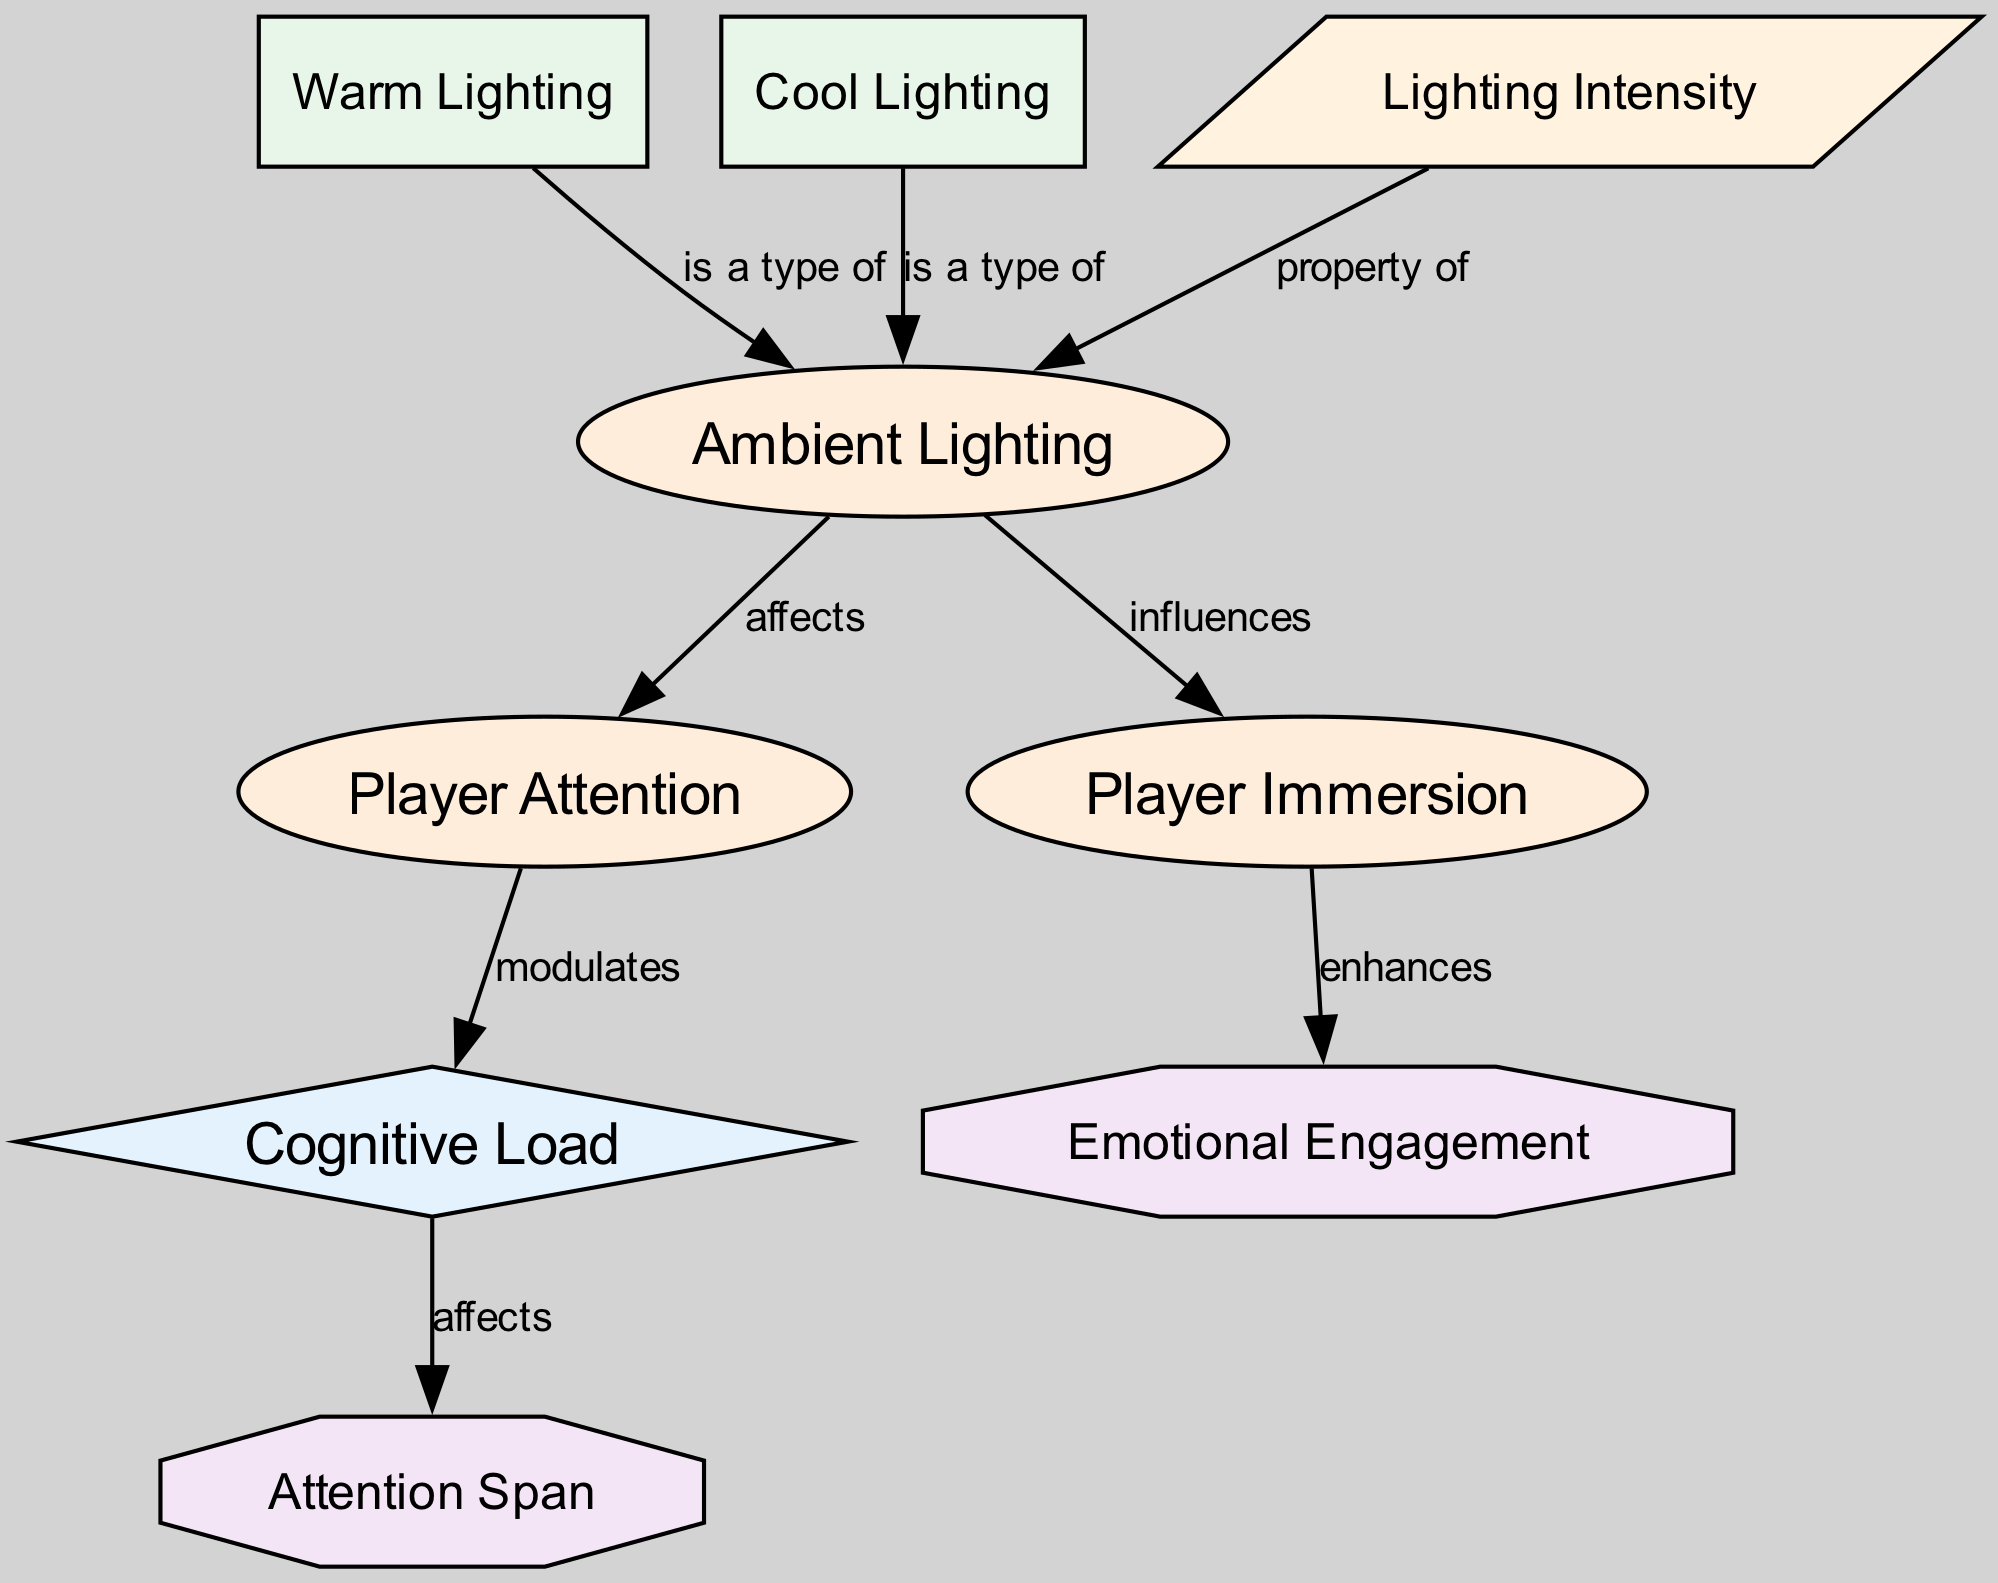What is the label of the node that represents player involvement? The node representing player involvement is labeled "Player Immersion" which shows the conceptual aspect of how ambient lighting influences the level of immersion players feel when engaging with video games.
Answer: Player Immersion How many nodes are there in the diagram? By counting each of the listed nodes under the "nodes" section in the diagram data, we find there are eight distinct nodes which include concepts, mechanisms, types, properties, and attributes.
Answer: 8 What type of relationship exists between Ambient Lighting and Player Attention? The relationship between Ambient Lighting and Player Attention is characterized as affecting, indicating that changes in ambient lighting directly influence how much attention players pay in the game.
Answer: affects Which two types of lighting are identified in the diagram? The two types of lighting identified in the diagram are "Warm Lighting" and "Cool Lighting," which serve as examples of how ambient lighting can be categorized within the context of visual games.
Answer: Warm Lighting, Cool Lighting What does Player Immersion enhance according to the diagram? The diagram states that Player Immersion enhances Emotional Engagement, highlighting the connection that deeper immersion can lead to increased emotional involvement in the gaming experience.
Answer: Emotional Engagement What effect does Cognitive Load have on Attention Span? The diagram indicates that Cognitive Load affects Attention Span, revealing that the mental effort put into processing information can influence how long players can maintain their attention.
Answer: affects What is a property of Ambient Lighting? The diagram specifies that Lighting Intensity is a property of Ambient Lighting, representing how the brightness level in the environment can influence player experience.
Answer: Lighting Intensity How does Player Attention modulate Cognitive Load? According to the diagram, Player Attention modulates Cognitive Load, signifying that higher levels of attention can either increase or decrease the cognitive load depending on the context of the game experience.
Answer: modulates How do Lighting types contribute to Ambient Lighting? The diagram shows that both Warm Lighting and Cool Lighting are types of Ambient Lighting, indicating that they fall under this broader category which impacts player experience alongside other factors.
Answer: is a type of 